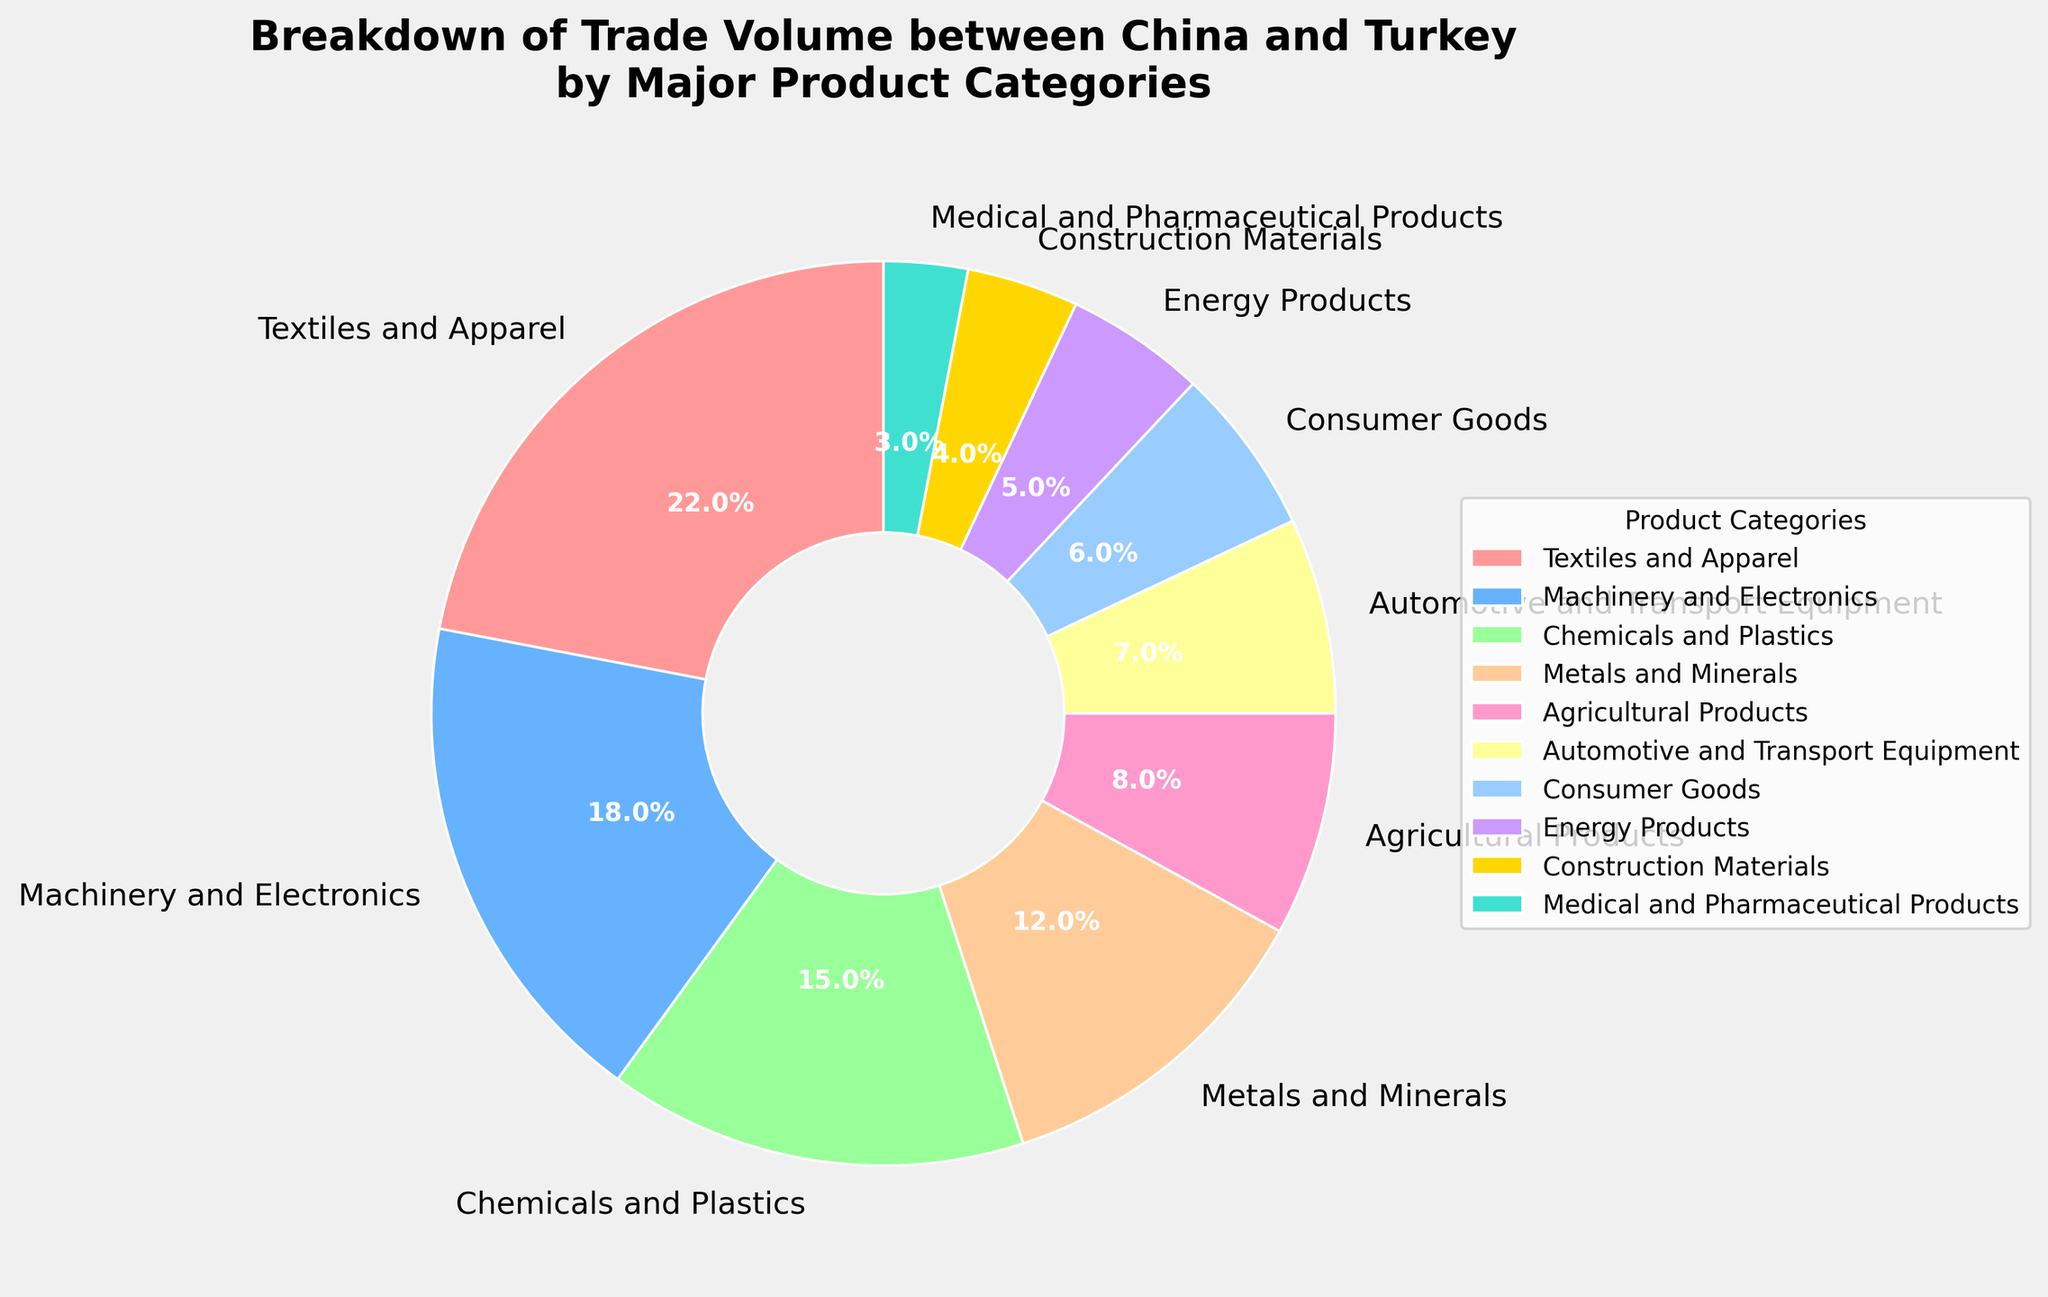What is the largest category in the trade volume between China and Turkey? The largest category can be identified by the largest segment in the pie chart. The label with the highest percentage should be the one.
Answer: Textiles and Apparel Which product categories together make up at least half of the trade volume? To determine which categories together constitute at least 50%, add up the percentages until reaching or exceeding 50%. Textiles and Apparel (22%) + Machinery and Electronics (18%) + Chemicals and Plastics (15%) equals 55%.
Answer: Textiles and Apparel, Machinery and Electronics, Chemicals and Plastics What is the difference in trade volume percentage between Machinery and Electronics and Metals and Minerals? First, find the percentages for both categories, which are Machinery and Electronics (18%) and Metals and Minerals (12%). Subtract the smaller percentage from the larger one. 18% - 12% = 6%.
Answer: 6% Which category has a smaller trade volume: Energy Products or Construction Materials? Compare the percentages of both categories. Energy Products have 5% and Construction Materials have 4%. The category with the smaller percentage is Construction Materials.
Answer: Construction Materials How does the percentage of Automotive and Transport Equipment compare to that of Consumer Goods? Examine the pie chart to find percentages for both categories: Automotive and Transport Equipment (7%) and Consumer Goods (6%). Compare the two values directly; Automotive and Transport Equipment is slightly larger.
Answer: Automotive and Transport Equipment is larger Which colored segment represents Agricultural Products? Identify the color associated with the 8% segment, labeled as Agricultural Products. Based on the custom color palette, it should correspond to one of the prescribed colors.
Answer: Yellow What is the combined trade volume percentage of Textiles and Apparel, and Consumer Goods? Add the percentages of the two categories: Textiles and Apparel (22%) and Consumer Goods (6%). 22% + 6% = 28%.
Answer: 28% Is the trade volume for Medical and Pharmaceutical Products greater than for Energy Products? Compare the percentages visually. Medical and Pharmaceutical Products are at 3% and Energy Products are at 5%. Hence, Energy Products have a greater trade volume.
Answer: No What percentage of the trade volume is attributed to categories with less than 10% each? Sum the percentages of the categories where each has less than 10%: Agricultural Products (8%), Automotive and Transport Equipment (7%), Consumer Goods (6%), Energy Products (5%), Construction Materials (4%), and Medical and Pharmaceutical Products (3%). 8% + 7% + 6% + 5% + 4% + 3% = 33%.
Answer: 33% Between Consumer Goods and Chemicals and Plastics, which category has a larger trade volume percentage? Look for the percentages in the pie chart. Consumer Goods make up 6%, while Chemicals and Plastics account for 15%. The category with the larger percentage is Chemicals and Plastics.
Answer: Chemicals and Plastics 